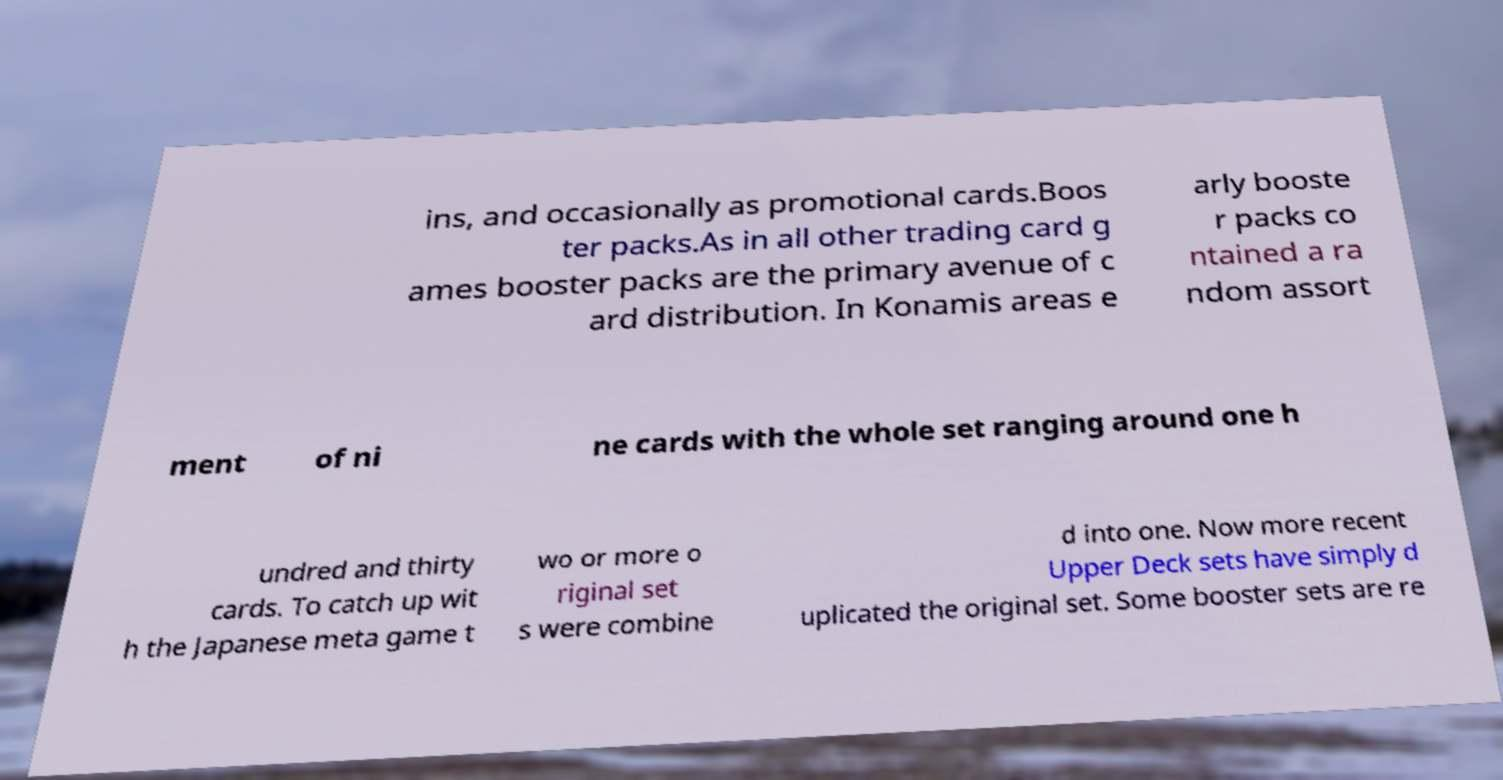I need the written content from this picture converted into text. Can you do that? ins, and occasionally as promotional cards.Boos ter packs.As in all other trading card g ames booster packs are the primary avenue of c ard distribution. In Konamis areas e arly booste r packs co ntained a ra ndom assort ment of ni ne cards with the whole set ranging around one h undred and thirty cards. To catch up wit h the Japanese meta game t wo or more o riginal set s were combine d into one. Now more recent Upper Deck sets have simply d uplicated the original set. Some booster sets are re 